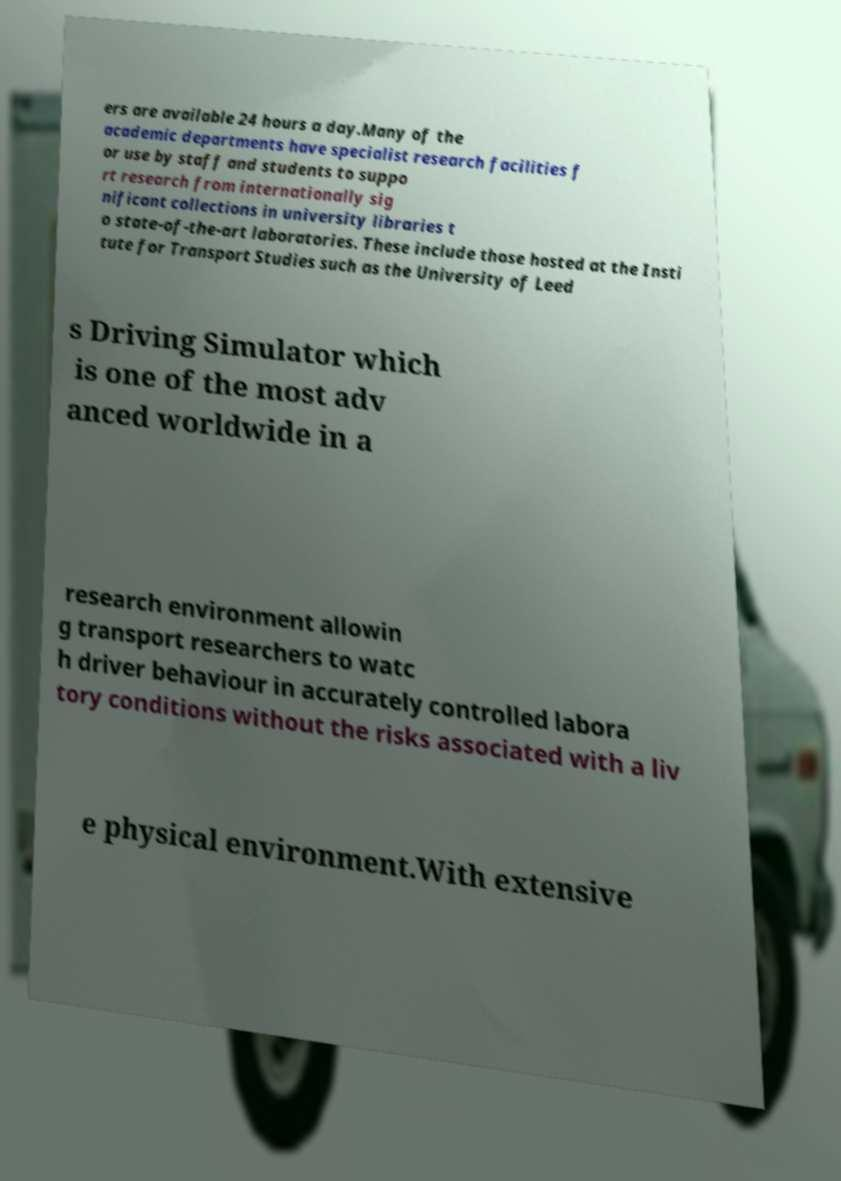Please read and relay the text visible in this image. What does it say? ers are available 24 hours a day.Many of the academic departments have specialist research facilities f or use by staff and students to suppo rt research from internationally sig nificant collections in university libraries t o state-of-the-art laboratories. These include those hosted at the Insti tute for Transport Studies such as the University of Leed s Driving Simulator which is one of the most adv anced worldwide in a research environment allowin g transport researchers to watc h driver behaviour in accurately controlled labora tory conditions without the risks associated with a liv e physical environment.With extensive 